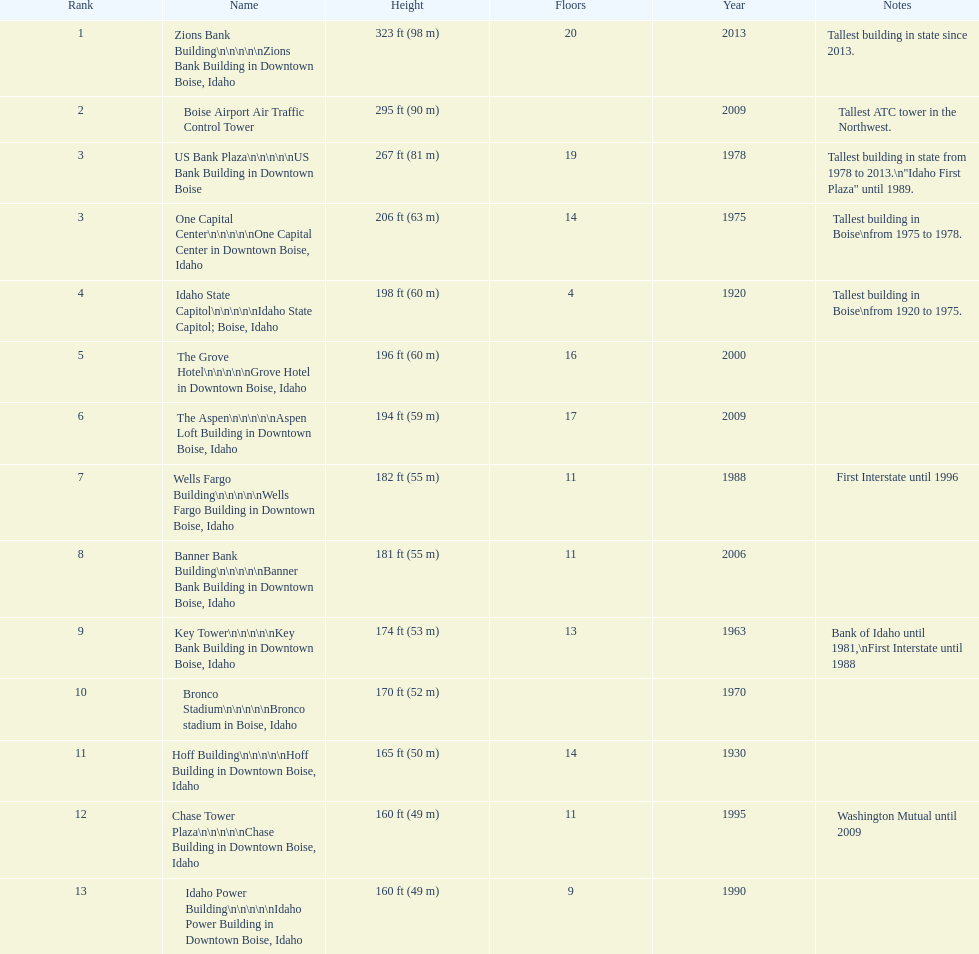What is the number of floors of the oldest building? 4. 